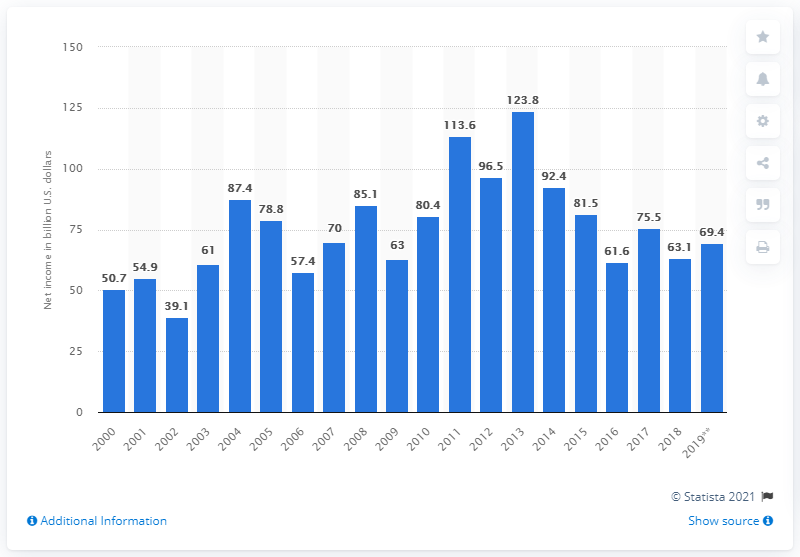List a handful of essential elements in this visual. In 2018, the total net farm income in the United States was 63.1. 